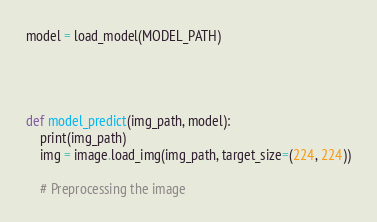Convert code to text. <code><loc_0><loc_0><loc_500><loc_500><_Python_>model = load_model(MODEL_PATH)




def model_predict(img_path, model):
    print(img_path)
    img = image.load_img(img_path, target_size=(224, 224))

    # Preprocessing the image</code> 